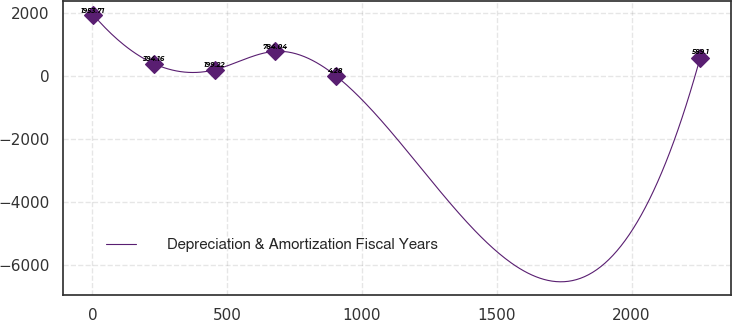<chart> <loc_0><loc_0><loc_500><loc_500><line_chart><ecel><fcel>Depreciation & Amortization Fiscal Years<nl><fcel>2.72<fcel>1953.71<nl><fcel>227.93<fcel>394.16<nl><fcel>453.14<fcel>199.22<nl><fcel>678.35<fcel>784.04<nl><fcel>903.56<fcel>4.28<nl><fcel>2254.82<fcel>589.1<nl></chart> 